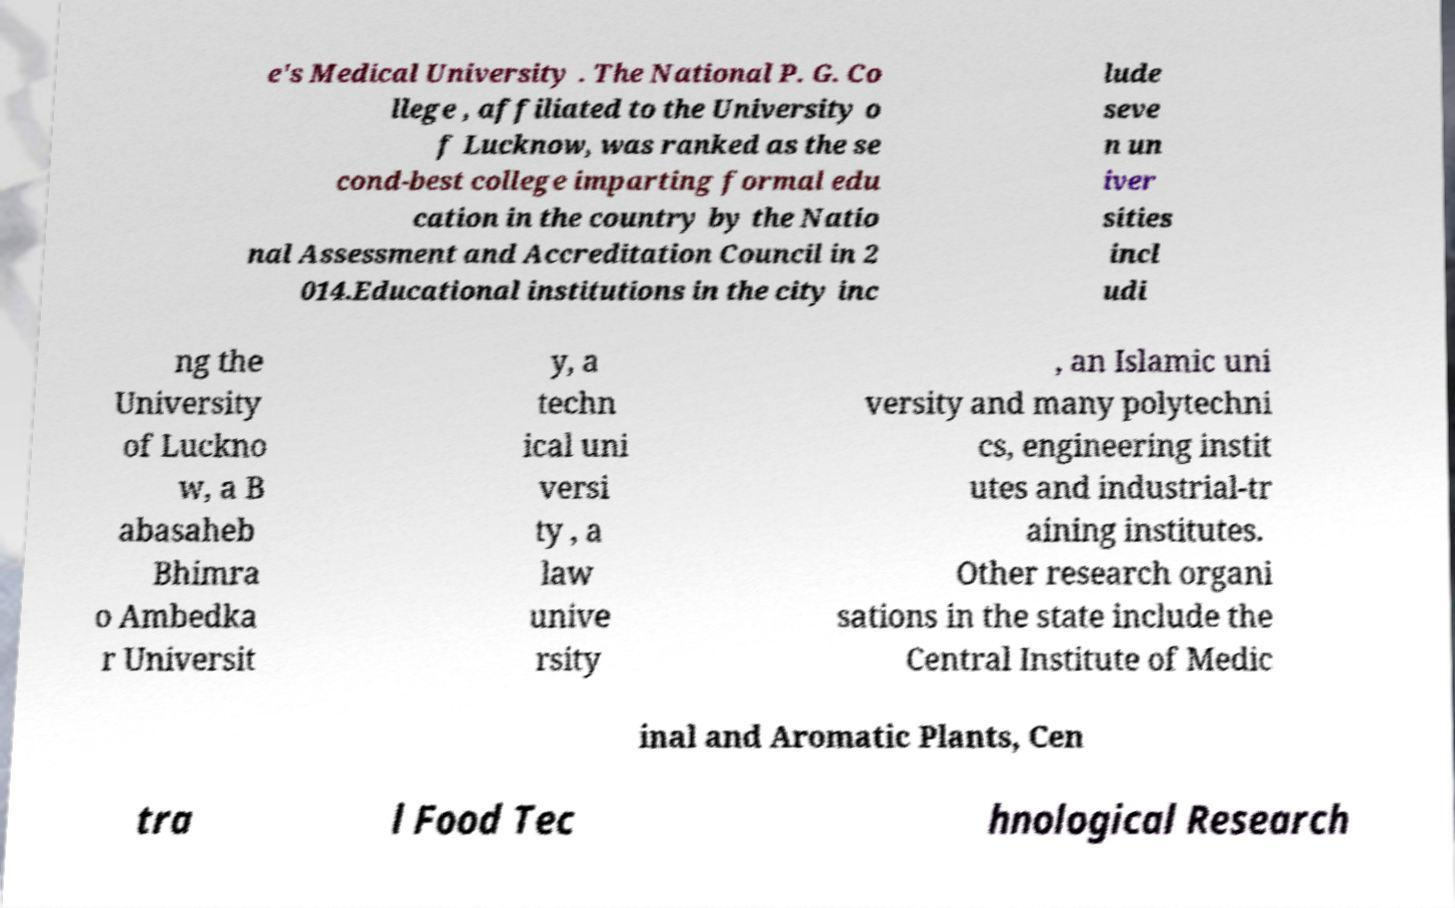I need the written content from this picture converted into text. Can you do that? e's Medical University . The National P. G. Co llege , affiliated to the University o f Lucknow, was ranked as the se cond-best college imparting formal edu cation in the country by the Natio nal Assessment and Accreditation Council in 2 014.Educational institutions in the city inc lude seve n un iver sities incl udi ng the University of Luckno w, a B abasaheb Bhimra o Ambedka r Universit y, a techn ical uni versi ty , a law unive rsity , an Islamic uni versity and many polytechni cs, engineering instit utes and industrial-tr aining institutes. Other research organi sations in the state include the Central Institute of Medic inal and Aromatic Plants, Cen tra l Food Tec hnological Research 